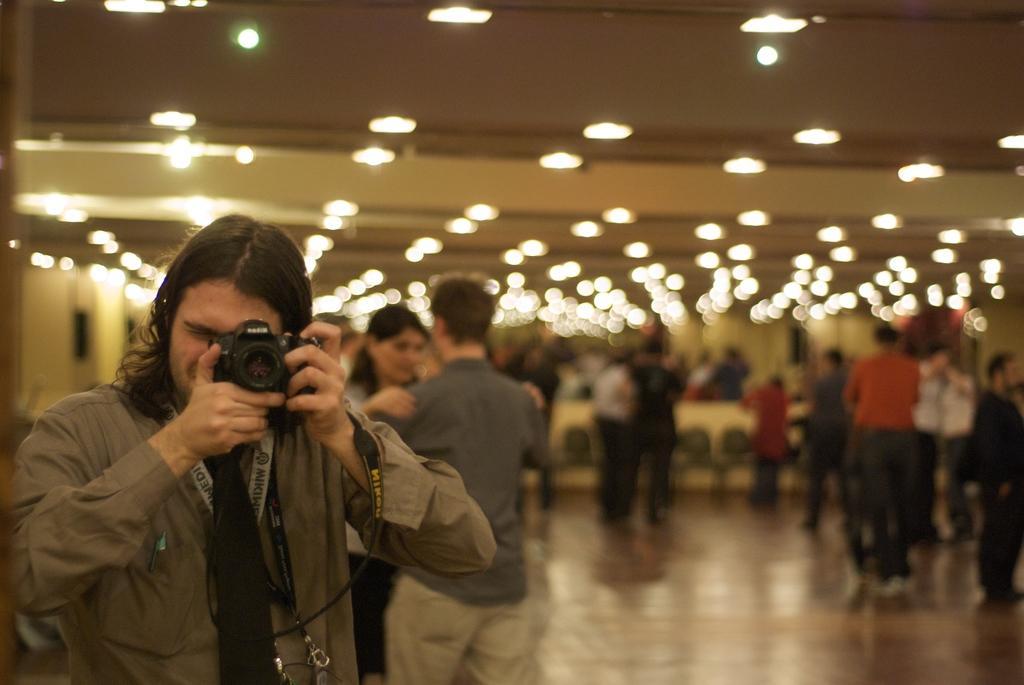Can you describe this image briefly? As we can see in the image there are lights, few people standing here and there and the man who is standing here is holding camera. 